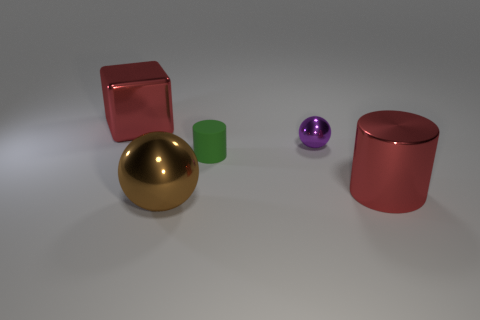Are there any other things that have the same material as the green thing?
Give a very brief answer. No. There is a red object in front of the tiny cylinder; does it have the same shape as the brown shiny object?
Offer a very short reply. No. What color is the shiny object to the left of the large sphere?
Your answer should be compact. Red. How many cylinders are red things or tiny objects?
Your answer should be very brief. 2. There is a red metal thing left of the large brown metallic object that is left of the small purple metallic ball; what size is it?
Offer a very short reply. Large. There is a big metal cylinder; is it the same color as the ball that is in front of the tiny purple ball?
Your response must be concise. No. There is a small matte thing; how many small cylinders are left of it?
Provide a short and direct response. 0. Is the number of purple spheres less than the number of large purple metal spheres?
Offer a terse response. No. How big is the object that is both right of the brown metallic object and on the left side of the small purple sphere?
Your response must be concise. Small. Do the large thing behind the small green object and the small sphere have the same color?
Your response must be concise. No. 